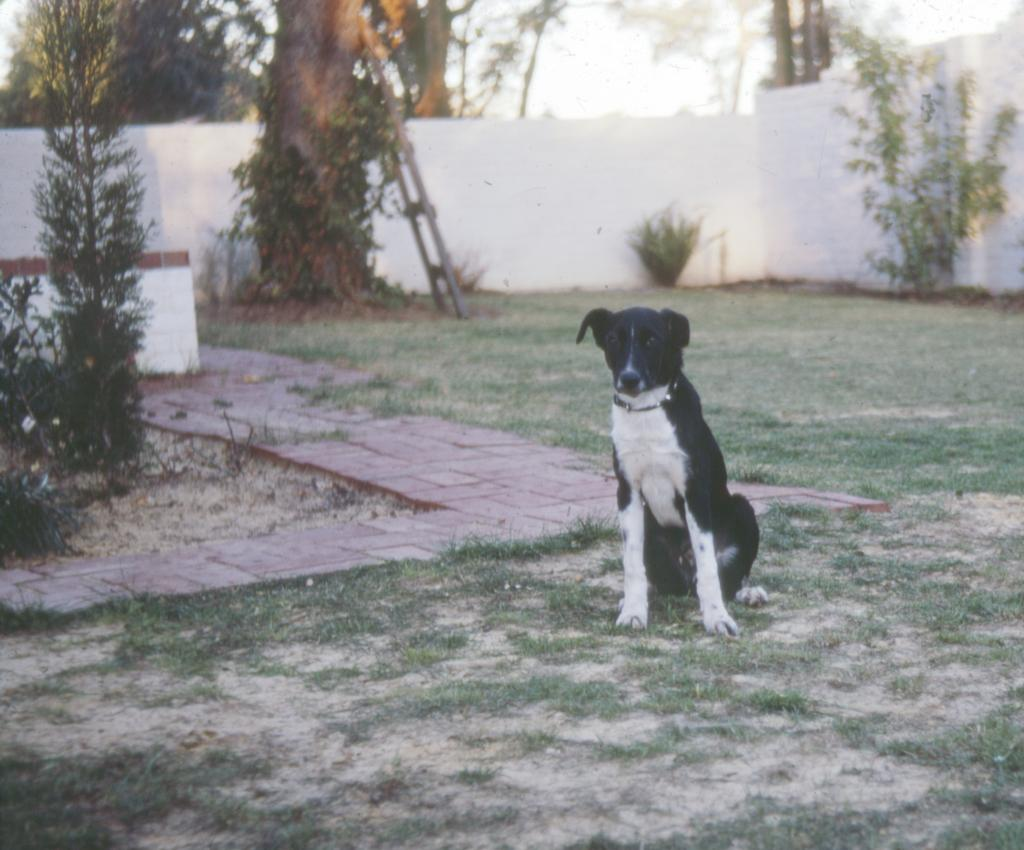What type of animal is in the image? There is a dog in the image. Can you describe the color of the dog? The dog is white and black in color. What can be seen in the background of the image? There are trees, a ladder, and a white wall visible in the background. What is the color of the sky in the image? The sky is visible and appears to be white in color. Where can the rats be found in the image? There are no rats present in the image. What type of credit can be seen on the dog's collar in the image? There is no credit or collar visible on the dog in the image. 